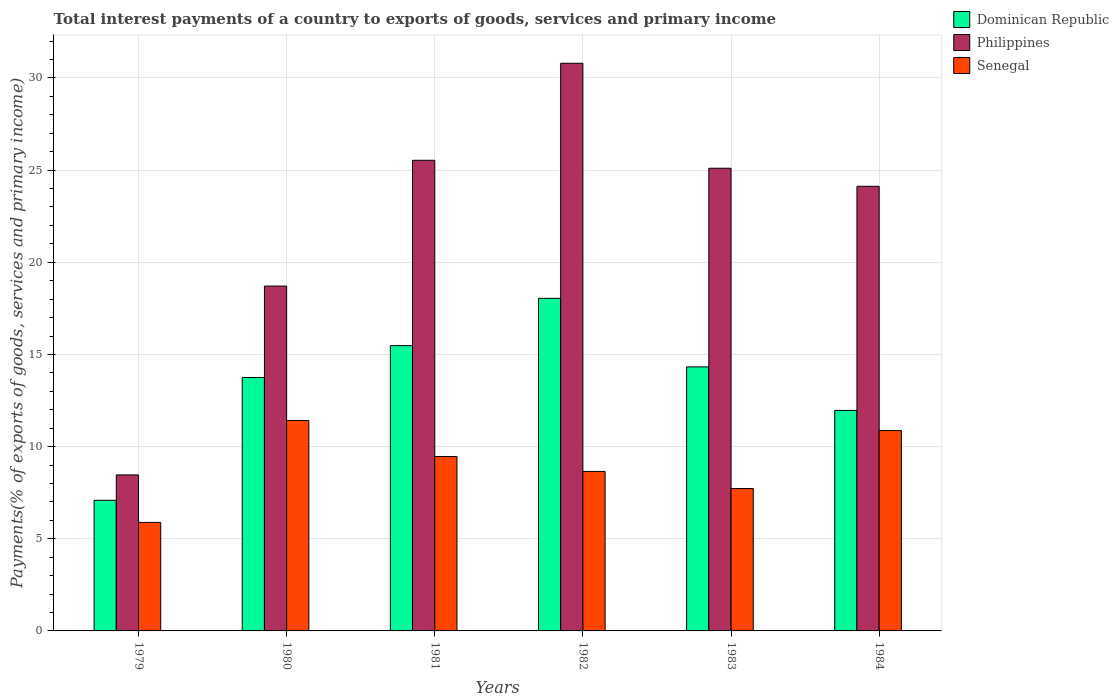Are the number of bars on each tick of the X-axis equal?
Keep it short and to the point. Yes. How many bars are there on the 4th tick from the left?
Offer a terse response. 3. What is the label of the 1st group of bars from the left?
Offer a terse response. 1979. In how many cases, is the number of bars for a given year not equal to the number of legend labels?
Ensure brevity in your answer.  0. What is the total interest payments in Dominican Republic in 1983?
Make the answer very short. 14.32. Across all years, what is the maximum total interest payments in Dominican Republic?
Your answer should be very brief. 18.04. Across all years, what is the minimum total interest payments in Dominican Republic?
Provide a short and direct response. 7.09. In which year was the total interest payments in Philippines maximum?
Ensure brevity in your answer.  1982. In which year was the total interest payments in Senegal minimum?
Provide a short and direct response. 1979. What is the total total interest payments in Philippines in the graph?
Keep it short and to the point. 132.73. What is the difference between the total interest payments in Philippines in 1980 and that in 1983?
Provide a succinct answer. -6.39. What is the difference between the total interest payments in Philippines in 1982 and the total interest payments in Dominican Republic in 1980?
Your response must be concise. 17.05. What is the average total interest payments in Philippines per year?
Offer a terse response. 22.12. In the year 1984, what is the difference between the total interest payments in Senegal and total interest payments in Dominican Republic?
Provide a succinct answer. -1.09. What is the ratio of the total interest payments in Senegal in 1979 to that in 1983?
Give a very brief answer. 0.76. Is the total interest payments in Dominican Republic in 1981 less than that in 1984?
Make the answer very short. No. What is the difference between the highest and the second highest total interest payments in Senegal?
Offer a terse response. 0.54. What is the difference between the highest and the lowest total interest payments in Dominican Republic?
Your answer should be compact. 10.96. In how many years, is the total interest payments in Senegal greater than the average total interest payments in Senegal taken over all years?
Offer a very short reply. 3. Is the sum of the total interest payments in Dominican Republic in 1980 and 1984 greater than the maximum total interest payments in Philippines across all years?
Give a very brief answer. No. What does the 1st bar from the left in 1980 represents?
Offer a very short reply. Dominican Republic. What does the 3rd bar from the right in 1983 represents?
Keep it short and to the point. Dominican Republic. Is it the case that in every year, the sum of the total interest payments in Senegal and total interest payments in Dominican Republic is greater than the total interest payments in Philippines?
Your response must be concise. No. How many bars are there?
Your answer should be compact. 18. Are all the bars in the graph horizontal?
Ensure brevity in your answer.  No. How many years are there in the graph?
Make the answer very short. 6. What is the difference between two consecutive major ticks on the Y-axis?
Give a very brief answer. 5. Does the graph contain any zero values?
Your response must be concise. No. Does the graph contain grids?
Give a very brief answer. Yes. How many legend labels are there?
Keep it short and to the point. 3. What is the title of the graph?
Your response must be concise. Total interest payments of a country to exports of goods, services and primary income. Does "Lesotho" appear as one of the legend labels in the graph?
Make the answer very short. No. What is the label or title of the X-axis?
Provide a succinct answer. Years. What is the label or title of the Y-axis?
Your answer should be very brief. Payments(% of exports of goods, services and primary income). What is the Payments(% of exports of goods, services and primary income) of Dominican Republic in 1979?
Offer a terse response. 7.09. What is the Payments(% of exports of goods, services and primary income) of Philippines in 1979?
Offer a very short reply. 8.46. What is the Payments(% of exports of goods, services and primary income) of Senegal in 1979?
Ensure brevity in your answer.  5.89. What is the Payments(% of exports of goods, services and primary income) of Dominican Republic in 1980?
Make the answer very short. 13.75. What is the Payments(% of exports of goods, services and primary income) of Philippines in 1980?
Provide a succinct answer. 18.71. What is the Payments(% of exports of goods, services and primary income) of Senegal in 1980?
Provide a succinct answer. 11.41. What is the Payments(% of exports of goods, services and primary income) of Dominican Republic in 1981?
Offer a terse response. 15.48. What is the Payments(% of exports of goods, services and primary income) of Philippines in 1981?
Provide a short and direct response. 25.53. What is the Payments(% of exports of goods, services and primary income) in Senegal in 1981?
Offer a terse response. 9.46. What is the Payments(% of exports of goods, services and primary income) of Dominican Republic in 1982?
Offer a very short reply. 18.04. What is the Payments(% of exports of goods, services and primary income) in Philippines in 1982?
Ensure brevity in your answer.  30.8. What is the Payments(% of exports of goods, services and primary income) of Senegal in 1982?
Give a very brief answer. 8.65. What is the Payments(% of exports of goods, services and primary income) of Dominican Republic in 1983?
Your response must be concise. 14.32. What is the Payments(% of exports of goods, services and primary income) in Philippines in 1983?
Keep it short and to the point. 25.1. What is the Payments(% of exports of goods, services and primary income) in Senegal in 1983?
Offer a very short reply. 7.72. What is the Payments(% of exports of goods, services and primary income) in Dominican Republic in 1984?
Your response must be concise. 11.96. What is the Payments(% of exports of goods, services and primary income) of Philippines in 1984?
Ensure brevity in your answer.  24.12. What is the Payments(% of exports of goods, services and primary income) of Senegal in 1984?
Provide a short and direct response. 10.87. Across all years, what is the maximum Payments(% of exports of goods, services and primary income) of Dominican Republic?
Your answer should be very brief. 18.04. Across all years, what is the maximum Payments(% of exports of goods, services and primary income) of Philippines?
Make the answer very short. 30.8. Across all years, what is the maximum Payments(% of exports of goods, services and primary income) of Senegal?
Your answer should be compact. 11.41. Across all years, what is the minimum Payments(% of exports of goods, services and primary income) of Dominican Republic?
Your response must be concise. 7.09. Across all years, what is the minimum Payments(% of exports of goods, services and primary income) of Philippines?
Your response must be concise. 8.46. Across all years, what is the minimum Payments(% of exports of goods, services and primary income) in Senegal?
Your answer should be very brief. 5.89. What is the total Payments(% of exports of goods, services and primary income) in Dominican Republic in the graph?
Make the answer very short. 80.65. What is the total Payments(% of exports of goods, services and primary income) of Philippines in the graph?
Your answer should be very brief. 132.73. What is the total Payments(% of exports of goods, services and primary income) in Senegal in the graph?
Keep it short and to the point. 54.01. What is the difference between the Payments(% of exports of goods, services and primary income) in Dominican Republic in 1979 and that in 1980?
Offer a terse response. -6.66. What is the difference between the Payments(% of exports of goods, services and primary income) of Philippines in 1979 and that in 1980?
Keep it short and to the point. -10.25. What is the difference between the Payments(% of exports of goods, services and primary income) of Senegal in 1979 and that in 1980?
Provide a succinct answer. -5.53. What is the difference between the Payments(% of exports of goods, services and primary income) of Dominican Republic in 1979 and that in 1981?
Keep it short and to the point. -8.39. What is the difference between the Payments(% of exports of goods, services and primary income) in Philippines in 1979 and that in 1981?
Your answer should be compact. -17.07. What is the difference between the Payments(% of exports of goods, services and primary income) of Senegal in 1979 and that in 1981?
Your answer should be compact. -3.57. What is the difference between the Payments(% of exports of goods, services and primary income) in Dominican Republic in 1979 and that in 1982?
Provide a succinct answer. -10.96. What is the difference between the Payments(% of exports of goods, services and primary income) in Philippines in 1979 and that in 1982?
Provide a succinct answer. -22.33. What is the difference between the Payments(% of exports of goods, services and primary income) of Senegal in 1979 and that in 1982?
Keep it short and to the point. -2.77. What is the difference between the Payments(% of exports of goods, services and primary income) of Dominican Republic in 1979 and that in 1983?
Ensure brevity in your answer.  -7.24. What is the difference between the Payments(% of exports of goods, services and primary income) in Philippines in 1979 and that in 1983?
Your answer should be compact. -16.64. What is the difference between the Payments(% of exports of goods, services and primary income) in Senegal in 1979 and that in 1983?
Keep it short and to the point. -1.84. What is the difference between the Payments(% of exports of goods, services and primary income) of Dominican Republic in 1979 and that in 1984?
Offer a very short reply. -4.88. What is the difference between the Payments(% of exports of goods, services and primary income) in Philippines in 1979 and that in 1984?
Provide a short and direct response. -15.66. What is the difference between the Payments(% of exports of goods, services and primary income) of Senegal in 1979 and that in 1984?
Provide a short and direct response. -4.98. What is the difference between the Payments(% of exports of goods, services and primary income) in Dominican Republic in 1980 and that in 1981?
Your response must be concise. -1.73. What is the difference between the Payments(% of exports of goods, services and primary income) of Philippines in 1980 and that in 1981?
Provide a short and direct response. -6.82. What is the difference between the Payments(% of exports of goods, services and primary income) in Senegal in 1980 and that in 1981?
Your response must be concise. 1.95. What is the difference between the Payments(% of exports of goods, services and primary income) in Dominican Republic in 1980 and that in 1982?
Give a very brief answer. -4.29. What is the difference between the Payments(% of exports of goods, services and primary income) of Philippines in 1980 and that in 1982?
Provide a short and direct response. -12.09. What is the difference between the Payments(% of exports of goods, services and primary income) in Senegal in 1980 and that in 1982?
Ensure brevity in your answer.  2.76. What is the difference between the Payments(% of exports of goods, services and primary income) of Dominican Republic in 1980 and that in 1983?
Your answer should be very brief. -0.58. What is the difference between the Payments(% of exports of goods, services and primary income) in Philippines in 1980 and that in 1983?
Make the answer very short. -6.39. What is the difference between the Payments(% of exports of goods, services and primary income) in Senegal in 1980 and that in 1983?
Ensure brevity in your answer.  3.69. What is the difference between the Payments(% of exports of goods, services and primary income) of Dominican Republic in 1980 and that in 1984?
Offer a terse response. 1.79. What is the difference between the Payments(% of exports of goods, services and primary income) of Philippines in 1980 and that in 1984?
Your answer should be very brief. -5.41. What is the difference between the Payments(% of exports of goods, services and primary income) in Senegal in 1980 and that in 1984?
Provide a succinct answer. 0.54. What is the difference between the Payments(% of exports of goods, services and primary income) of Dominican Republic in 1981 and that in 1982?
Your response must be concise. -2.57. What is the difference between the Payments(% of exports of goods, services and primary income) in Philippines in 1981 and that in 1982?
Ensure brevity in your answer.  -5.26. What is the difference between the Payments(% of exports of goods, services and primary income) of Senegal in 1981 and that in 1982?
Your answer should be compact. 0.81. What is the difference between the Payments(% of exports of goods, services and primary income) in Dominican Republic in 1981 and that in 1983?
Your response must be concise. 1.15. What is the difference between the Payments(% of exports of goods, services and primary income) of Philippines in 1981 and that in 1983?
Your answer should be compact. 0.43. What is the difference between the Payments(% of exports of goods, services and primary income) in Senegal in 1981 and that in 1983?
Your answer should be very brief. 1.74. What is the difference between the Payments(% of exports of goods, services and primary income) of Dominican Republic in 1981 and that in 1984?
Ensure brevity in your answer.  3.52. What is the difference between the Payments(% of exports of goods, services and primary income) in Philippines in 1981 and that in 1984?
Ensure brevity in your answer.  1.41. What is the difference between the Payments(% of exports of goods, services and primary income) of Senegal in 1981 and that in 1984?
Offer a very short reply. -1.41. What is the difference between the Payments(% of exports of goods, services and primary income) of Dominican Republic in 1982 and that in 1983?
Offer a very short reply. 3.72. What is the difference between the Payments(% of exports of goods, services and primary income) of Philippines in 1982 and that in 1983?
Give a very brief answer. 5.7. What is the difference between the Payments(% of exports of goods, services and primary income) in Senegal in 1982 and that in 1983?
Offer a very short reply. 0.93. What is the difference between the Payments(% of exports of goods, services and primary income) in Dominican Republic in 1982 and that in 1984?
Keep it short and to the point. 6.08. What is the difference between the Payments(% of exports of goods, services and primary income) in Philippines in 1982 and that in 1984?
Provide a succinct answer. 6.67. What is the difference between the Payments(% of exports of goods, services and primary income) of Senegal in 1982 and that in 1984?
Your answer should be compact. -2.22. What is the difference between the Payments(% of exports of goods, services and primary income) in Dominican Republic in 1983 and that in 1984?
Your answer should be very brief. 2.36. What is the difference between the Payments(% of exports of goods, services and primary income) in Philippines in 1983 and that in 1984?
Make the answer very short. 0.98. What is the difference between the Payments(% of exports of goods, services and primary income) in Senegal in 1983 and that in 1984?
Provide a short and direct response. -3.15. What is the difference between the Payments(% of exports of goods, services and primary income) of Dominican Republic in 1979 and the Payments(% of exports of goods, services and primary income) of Philippines in 1980?
Give a very brief answer. -11.62. What is the difference between the Payments(% of exports of goods, services and primary income) of Dominican Republic in 1979 and the Payments(% of exports of goods, services and primary income) of Senegal in 1980?
Ensure brevity in your answer.  -4.33. What is the difference between the Payments(% of exports of goods, services and primary income) of Philippines in 1979 and the Payments(% of exports of goods, services and primary income) of Senegal in 1980?
Keep it short and to the point. -2.95. What is the difference between the Payments(% of exports of goods, services and primary income) of Dominican Republic in 1979 and the Payments(% of exports of goods, services and primary income) of Philippines in 1981?
Provide a succinct answer. -18.45. What is the difference between the Payments(% of exports of goods, services and primary income) in Dominican Republic in 1979 and the Payments(% of exports of goods, services and primary income) in Senegal in 1981?
Keep it short and to the point. -2.37. What is the difference between the Payments(% of exports of goods, services and primary income) in Philippines in 1979 and the Payments(% of exports of goods, services and primary income) in Senegal in 1981?
Make the answer very short. -1. What is the difference between the Payments(% of exports of goods, services and primary income) of Dominican Republic in 1979 and the Payments(% of exports of goods, services and primary income) of Philippines in 1982?
Offer a very short reply. -23.71. What is the difference between the Payments(% of exports of goods, services and primary income) in Dominican Republic in 1979 and the Payments(% of exports of goods, services and primary income) in Senegal in 1982?
Ensure brevity in your answer.  -1.57. What is the difference between the Payments(% of exports of goods, services and primary income) of Philippines in 1979 and the Payments(% of exports of goods, services and primary income) of Senegal in 1982?
Offer a terse response. -0.19. What is the difference between the Payments(% of exports of goods, services and primary income) of Dominican Republic in 1979 and the Payments(% of exports of goods, services and primary income) of Philippines in 1983?
Keep it short and to the point. -18.02. What is the difference between the Payments(% of exports of goods, services and primary income) in Dominican Republic in 1979 and the Payments(% of exports of goods, services and primary income) in Senegal in 1983?
Keep it short and to the point. -0.64. What is the difference between the Payments(% of exports of goods, services and primary income) in Philippines in 1979 and the Payments(% of exports of goods, services and primary income) in Senegal in 1983?
Give a very brief answer. 0.74. What is the difference between the Payments(% of exports of goods, services and primary income) of Dominican Republic in 1979 and the Payments(% of exports of goods, services and primary income) of Philippines in 1984?
Offer a terse response. -17.04. What is the difference between the Payments(% of exports of goods, services and primary income) in Dominican Republic in 1979 and the Payments(% of exports of goods, services and primary income) in Senegal in 1984?
Provide a succinct answer. -3.78. What is the difference between the Payments(% of exports of goods, services and primary income) in Philippines in 1979 and the Payments(% of exports of goods, services and primary income) in Senegal in 1984?
Provide a succinct answer. -2.41. What is the difference between the Payments(% of exports of goods, services and primary income) of Dominican Republic in 1980 and the Payments(% of exports of goods, services and primary income) of Philippines in 1981?
Make the answer very short. -11.78. What is the difference between the Payments(% of exports of goods, services and primary income) of Dominican Republic in 1980 and the Payments(% of exports of goods, services and primary income) of Senegal in 1981?
Your answer should be compact. 4.29. What is the difference between the Payments(% of exports of goods, services and primary income) in Philippines in 1980 and the Payments(% of exports of goods, services and primary income) in Senegal in 1981?
Provide a short and direct response. 9.25. What is the difference between the Payments(% of exports of goods, services and primary income) in Dominican Republic in 1980 and the Payments(% of exports of goods, services and primary income) in Philippines in 1982?
Provide a short and direct response. -17.05. What is the difference between the Payments(% of exports of goods, services and primary income) in Dominican Republic in 1980 and the Payments(% of exports of goods, services and primary income) in Senegal in 1982?
Provide a succinct answer. 5.09. What is the difference between the Payments(% of exports of goods, services and primary income) in Philippines in 1980 and the Payments(% of exports of goods, services and primary income) in Senegal in 1982?
Your response must be concise. 10.06. What is the difference between the Payments(% of exports of goods, services and primary income) of Dominican Republic in 1980 and the Payments(% of exports of goods, services and primary income) of Philippines in 1983?
Give a very brief answer. -11.35. What is the difference between the Payments(% of exports of goods, services and primary income) of Dominican Republic in 1980 and the Payments(% of exports of goods, services and primary income) of Senegal in 1983?
Provide a short and direct response. 6.02. What is the difference between the Payments(% of exports of goods, services and primary income) of Philippines in 1980 and the Payments(% of exports of goods, services and primary income) of Senegal in 1983?
Provide a succinct answer. 10.99. What is the difference between the Payments(% of exports of goods, services and primary income) in Dominican Republic in 1980 and the Payments(% of exports of goods, services and primary income) in Philippines in 1984?
Give a very brief answer. -10.37. What is the difference between the Payments(% of exports of goods, services and primary income) of Dominican Republic in 1980 and the Payments(% of exports of goods, services and primary income) of Senegal in 1984?
Make the answer very short. 2.88. What is the difference between the Payments(% of exports of goods, services and primary income) of Philippines in 1980 and the Payments(% of exports of goods, services and primary income) of Senegal in 1984?
Provide a short and direct response. 7.84. What is the difference between the Payments(% of exports of goods, services and primary income) of Dominican Republic in 1981 and the Payments(% of exports of goods, services and primary income) of Philippines in 1982?
Provide a succinct answer. -15.32. What is the difference between the Payments(% of exports of goods, services and primary income) of Dominican Republic in 1981 and the Payments(% of exports of goods, services and primary income) of Senegal in 1982?
Your answer should be compact. 6.82. What is the difference between the Payments(% of exports of goods, services and primary income) in Philippines in 1981 and the Payments(% of exports of goods, services and primary income) in Senegal in 1982?
Offer a very short reply. 16.88. What is the difference between the Payments(% of exports of goods, services and primary income) in Dominican Republic in 1981 and the Payments(% of exports of goods, services and primary income) in Philippines in 1983?
Give a very brief answer. -9.62. What is the difference between the Payments(% of exports of goods, services and primary income) of Dominican Republic in 1981 and the Payments(% of exports of goods, services and primary income) of Senegal in 1983?
Provide a succinct answer. 7.75. What is the difference between the Payments(% of exports of goods, services and primary income) in Philippines in 1981 and the Payments(% of exports of goods, services and primary income) in Senegal in 1983?
Keep it short and to the point. 17.81. What is the difference between the Payments(% of exports of goods, services and primary income) of Dominican Republic in 1981 and the Payments(% of exports of goods, services and primary income) of Philippines in 1984?
Give a very brief answer. -8.64. What is the difference between the Payments(% of exports of goods, services and primary income) in Dominican Republic in 1981 and the Payments(% of exports of goods, services and primary income) in Senegal in 1984?
Keep it short and to the point. 4.61. What is the difference between the Payments(% of exports of goods, services and primary income) of Philippines in 1981 and the Payments(% of exports of goods, services and primary income) of Senegal in 1984?
Provide a succinct answer. 14.66. What is the difference between the Payments(% of exports of goods, services and primary income) of Dominican Republic in 1982 and the Payments(% of exports of goods, services and primary income) of Philippines in 1983?
Offer a very short reply. -7.06. What is the difference between the Payments(% of exports of goods, services and primary income) of Dominican Republic in 1982 and the Payments(% of exports of goods, services and primary income) of Senegal in 1983?
Keep it short and to the point. 10.32. What is the difference between the Payments(% of exports of goods, services and primary income) in Philippines in 1982 and the Payments(% of exports of goods, services and primary income) in Senegal in 1983?
Make the answer very short. 23.07. What is the difference between the Payments(% of exports of goods, services and primary income) in Dominican Republic in 1982 and the Payments(% of exports of goods, services and primary income) in Philippines in 1984?
Make the answer very short. -6.08. What is the difference between the Payments(% of exports of goods, services and primary income) of Dominican Republic in 1982 and the Payments(% of exports of goods, services and primary income) of Senegal in 1984?
Ensure brevity in your answer.  7.17. What is the difference between the Payments(% of exports of goods, services and primary income) of Philippines in 1982 and the Payments(% of exports of goods, services and primary income) of Senegal in 1984?
Provide a succinct answer. 19.93. What is the difference between the Payments(% of exports of goods, services and primary income) of Dominican Republic in 1983 and the Payments(% of exports of goods, services and primary income) of Philippines in 1984?
Offer a very short reply. -9.8. What is the difference between the Payments(% of exports of goods, services and primary income) of Dominican Republic in 1983 and the Payments(% of exports of goods, services and primary income) of Senegal in 1984?
Give a very brief answer. 3.45. What is the difference between the Payments(% of exports of goods, services and primary income) in Philippines in 1983 and the Payments(% of exports of goods, services and primary income) in Senegal in 1984?
Ensure brevity in your answer.  14.23. What is the average Payments(% of exports of goods, services and primary income) in Dominican Republic per year?
Ensure brevity in your answer.  13.44. What is the average Payments(% of exports of goods, services and primary income) in Philippines per year?
Provide a short and direct response. 22.12. What is the average Payments(% of exports of goods, services and primary income) of Senegal per year?
Provide a short and direct response. 9. In the year 1979, what is the difference between the Payments(% of exports of goods, services and primary income) in Dominican Republic and Payments(% of exports of goods, services and primary income) in Philippines?
Provide a short and direct response. -1.38. In the year 1979, what is the difference between the Payments(% of exports of goods, services and primary income) of Dominican Republic and Payments(% of exports of goods, services and primary income) of Senegal?
Keep it short and to the point. 1.2. In the year 1979, what is the difference between the Payments(% of exports of goods, services and primary income) of Philippines and Payments(% of exports of goods, services and primary income) of Senegal?
Provide a succinct answer. 2.58. In the year 1980, what is the difference between the Payments(% of exports of goods, services and primary income) of Dominican Republic and Payments(% of exports of goods, services and primary income) of Philippines?
Provide a short and direct response. -4.96. In the year 1980, what is the difference between the Payments(% of exports of goods, services and primary income) of Dominican Republic and Payments(% of exports of goods, services and primary income) of Senegal?
Offer a terse response. 2.33. In the year 1980, what is the difference between the Payments(% of exports of goods, services and primary income) in Philippines and Payments(% of exports of goods, services and primary income) in Senegal?
Provide a short and direct response. 7.3. In the year 1981, what is the difference between the Payments(% of exports of goods, services and primary income) of Dominican Republic and Payments(% of exports of goods, services and primary income) of Philippines?
Offer a terse response. -10.05. In the year 1981, what is the difference between the Payments(% of exports of goods, services and primary income) of Dominican Republic and Payments(% of exports of goods, services and primary income) of Senegal?
Your response must be concise. 6.02. In the year 1981, what is the difference between the Payments(% of exports of goods, services and primary income) of Philippines and Payments(% of exports of goods, services and primary income) of Senegal?
Keep it short and to the point. 16.07. In the year 1982, what is the difference between the Payments(% of exports of goods, services and primary income) of Dominican Republic and Payments(% of exports of goods, services and primary income) of Philippines?
Offer a terse response. -12.75. In the year 1982, what is the difference between the Payments(% of exports of goods, services and primary income) in Dominican Republic and Payments(% of exports of goods, services and primary income) in Senegal?
Offer a very short reply. 9.39. In the year 1982, what is the difference between the Payments(% of exports of goods, services and primary income) in Philippines and Payments(% of exports of goods, services and primary income) in Senegal?
Provide a short and direct response. 22.14. In the year 1983, what is the difference between the Payments(% of exports of goods, services and primary income) in Dominican Republic and Payments(% of exports of goods, services and primary income) in Philippines?
Provide a succinct answer. -10.78. In the year 1983, what is the difference between the Payments(% of exports of goods, services and primary income) of Dominican Republic and Payments(% of exports of goods, services and primary income) of Senegal?
Offer a very short reply. 6.6. In the year 1983, what is the difference between the Payments(% of exports of goods, services and primary income) of Philippines and Payments(% of exports of goods, services and primary income) of Senegal?
Make the answer very short. 17.38. In the year 1984, what is the difference between the Payments(% of exports of goods, services and primary income) of Dominican Republic and Payments(% of exports of goods, services and primary income) of Philippines?
Offer a terse response. -12.16. In the year 1984, what is the difference between the Payments(% of exports of goods, services and primary income) in Dominican Republic and Payments(% of exports of goods, services and primary income) in Senegal?
Provide a succinct answer. 1.09. In the year 1984, what is the difference between the Payments(% of exports of goods, services and primary income) in Philippines and Payments(% of exports of goods, services and primary income) in Senegal?
Provide a succinct answer. 13.25. What is the ratio of the Payments(% of exports of goods, services and primary income) in Dominican Republic in 1979 to that in 1980?
Make the answer very short. 0.52. What is the ratio of the Payments(% of exports of goods, services and primary income) in Philippines in 1979 to that in 1980?
Ensure brevity in your answer.  0.45. What is the ratio of the Payments(% of exports of goods, services and primary income) in Senegal in 1979 to that in 1980?
Ensure brevity in your answer.  0.52. What is the ratio of the Payments(% of exports of goods, services and primary income) in Dominican Republic in 1979 to that in 1981?
Offer a very short reply. 0.46. What is the ratio of the Payments(% of exports of goods, services and primary income) of Philippines in 1979 to that in 1981?
Offer a very short reply. 0.33. What is the ratio of the Payments(% of exports of goods, services and primary income) in Senegal in 1979 to that in 1981?
Give a very brief answer. 0.62. What is the ratio of the Payments(% of exports of goods, services and primary income) of Dominican Republic in 1979 to that in 1982?
Make the answer very short. 0.39. What is the ratio of the Payments(% of exports of goods, services and primary income) in Philippines in 1979 to that in 1982?
Give a very brief answer. 0.27. What is the ratio of the Payments(% of exports of goods, services and primary income) of Senegal in 1979 to that in 1982?
Your response must be concise. 0.68. What is the ratio of the Payments(% of exports of goods, services and primary income) in Dominican Republic in 1979 to that in 1983?
Offer a terse response. 0.49. What is the ratio of the Payments(% of exports of goods, services and primary income) of Philippines in 1979 to that in 1983?
Your response must be concise. 0.34. What is the ratio of the Payments(% of exports of goods, services and primary income) of Senegal in 1979 to that in 1983?
Your answer should be compact. 0.76. What is the ratio of the Payments(% of exports of goods, services and primary income) of Dominican Republic in 1979 to that in 1984?
Your answer should be very brief. 0.59. What is the ratio of the Payments(% of exports of goods, services and primary income) in Philippines in 1979 to that in 1984?
Your response must be concise. 0.35. What is the ratio of the Payments(% of exports of goods, services and primary income) of Senegal in 1979 to that in 1984?
Offer a very short reply. 0.54. What is the ratio of the Payments(% of exports of goods, services and primary income) in Dominican Republic in 1980 to that in 1981?
Your answer should be compact. 0.89. What is the ratio of the Payments(% of exports of goods, services and primary income) in Philippines in 1980 to that in 1981?
Your response must be concise. 0.73. What is the ratio of the Payments(% of exports of goods, services and primary income) of Senegal in 1980 to that in 1981?
Offer a terse response. 1.21. What is the ratio of the Payments(% of exports of goods, services and primary income) in Dominican Republic in 1980 to that in 1982?
Offer a terse response. 0.76. What is the ratio of the Payments(% of exports of goods, services and primary income) in Philippines in 1980 to that in 1982?
Offer a very short reply. 0.61. What is the ratio of the Payments(% of exports of goods, services and primary income) of Senegal in 1980 to that in 1982?
Provide a short and direct response. 1.32. What is the ratio of the Payments(% of exports of goods, services and primary income) of Dominican Republic in 1980 to that in 1983?
Keep it short and to the point. 0.96. What is the ratio of the Payments(% of exports of goods, services and primary income) in Philippines in 1980 to that in 1983?
Ensure brevity in your answer.  0.75. What is the ratio of the Payments(% of exports of goods, services and primary income) in Senegal in 1980 to that in 1983?
Provide a short and direct response. 1.48. What is the ratio of the Payments(% of exports of goods, services and primary income) in Dominican Republic in 1980 to that in 1984?
Your answer should be compact. 1.15. What is the ratio of the Payments(% of exports of goods, services and primary income) in Philippines in 1980 to that in 1984?
Offer a terse response. 0.78. What is the ratio of the Payments(% of exports of goods, services and primary income) of Senegal in 1980 to that in 1984?
Provide a succinct answer. 1.05. What is the ratio of the Payments(% of exports of goods, services and primary income) of Dominican Republic in 1981 to that in 1982?
Provide a succinct answer. 0.86. What is the ratio of the Payments(% of exports of goods, services and primary income) of Philippines in 1981 to that in 1982?
Give a very brief answer. 0.83. What is the ratio of the Payments(% of exports of goods, services and primary income) in Senegal in 1981 to that in 1982?
Give a very brief answer. 1.09. What is the ratio of the Payments(% of exports of goods, services and primary income) in Dominican Republic in 1981 to that in 1983?
Give a very brief answer. 1.08. What is the ratio of the Payments(% of exports of goods, services and primary income) in Philippines in 1981 to that in 1983?
Your answer should be compact. 1.02. What is the ratio of the Payments(% of exports of goods, services and primary income) of Senegal in 1981 to that in 1983?
Offer a very short reply. 1.22. What is the ratio of the Payments(% of exports of goods, services and primary income) in Dominican Republic in 1981 to that in 1984?
Provide a succinct answer. 1.29. What is the ratio of the Payments(% of exports of goods, services and primary income) of Philippines in 1981 to that in 1984?
Offer a terse response. 1.06. What is the ratio of the Payments(% of exports of goods, services and primary income) of Senegal in 1981 to that in 1984?
Your answer should be compact. 0.87. What is the ratio of the Payments(% of exports of goods, services and primary income) of Dominican Republic in 1982 to that in 1983?
Your answer should be very brief. 1.26. What is the ratio of the Payments(% of exports of goods, services and primary income) in Philippines in 1982 to that in 1983?
Make the answer very short. 1.23. What is the ratio of the Payments(% of exports of goods, services and primary income) in Senegal in 1982 to that in 1983?
Ensure brevity in your answer.  1.12. What is the ratio of the Payments(% of exports of goods, services and primary income) in Dominican Republic in 1982 to that in 1984?
Provide a succinct answer. 1.51. What is the ratio of the Payments(% of exports of goods, services and primary income) in Philippines in 1982 to that in 1984?
Keep it short and to the point. 1.28. What is the ratio of the Payments(% of exports of goods, services and primary income) of Senegal in 1982 to that in 1984?
Your response must be concise. 0.8. What is the ratio of the Payments(% of exports of goods, services and primary income) in Dominican Republic in 1983 to that in 1984?
Your answer should be compact. 1.2. What is the ratio of the Payments(% of exports of goods, services and primary income) in Philippines in 1983 to that in 1984?
Provide a short and direct response. 1.04. What is the ratio of the Payments(% of exports of goods, services and primary income) in Senegal in 1983 to that in 1984?
Offer a very short reply. 0.71. What is the difference between the highest and the second highest Payments(% of exports of goods, services and primary income) of Dominican Republic?
Make the answer very short. 2.57. What is the difference between the highest and the second highest Payments(% of exports of goods, services and primary income) in Philippines?
Offer a terse response. 5.26. What is the difference between the highest and the second highest Payments(% of exports of goods, services and primary income) of Senegal?
Give a very brief answer. 0.54. What is the difference between the highest and the lowest Payments(% of exports of goods, services and primary income) of Dominican Republic?
Your answer should be very brief. 10.96. What is the difference between the highest and the lowest Payments(% of exports of goods, services and primary income) in Philippines?
Keep it short and to the point. 22.33. What is the difference between the highest and the lowest Payments(% of exports of goods, services and primary income) in Senegal?
Give a very brief answer. 5.53. 